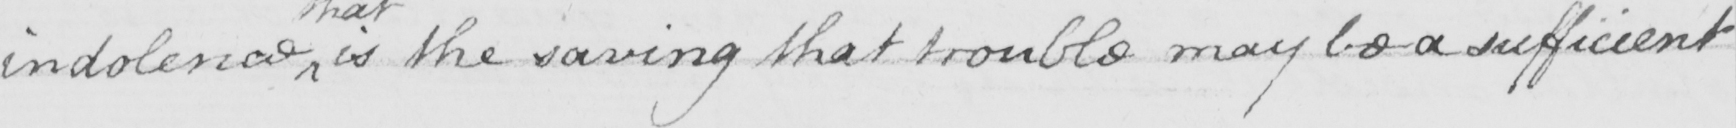Can you tell me what this handwritten text says? indolence is the saving that trouble may be a sufficient 